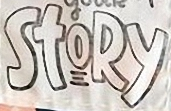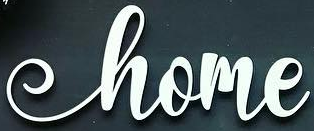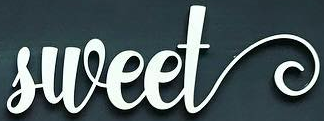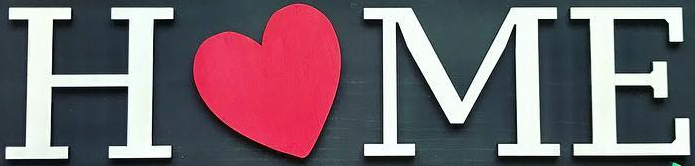Read the text content from these images in order, separated by a semicolon. StoRy; home; sweet; HOME 